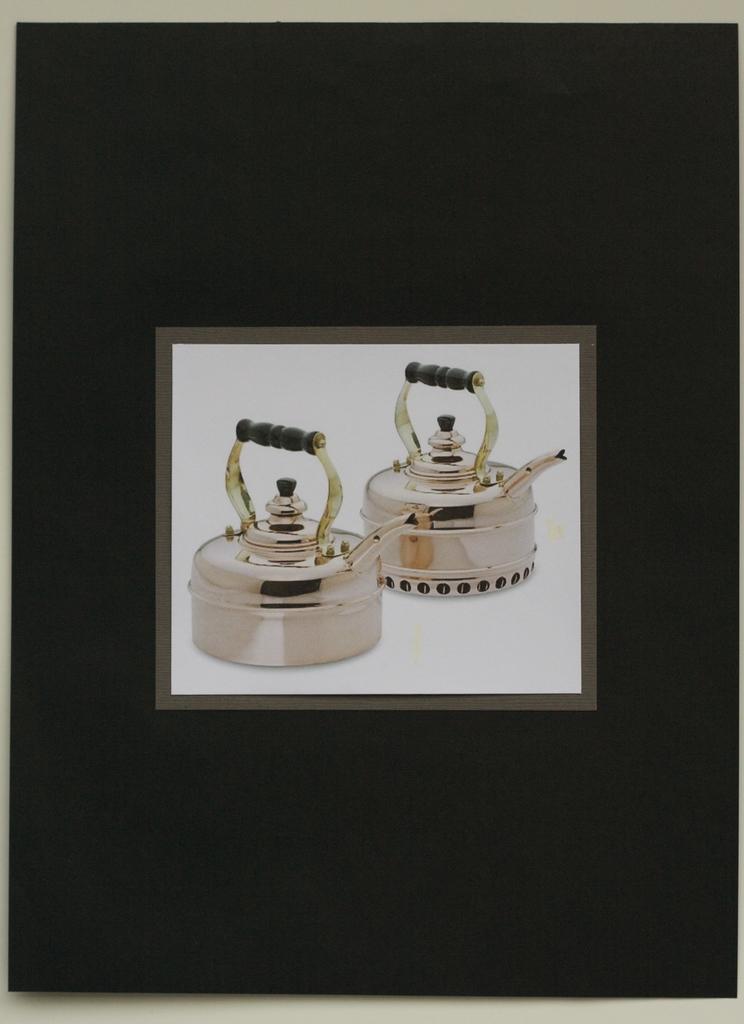Please provide a concise description of this image. In this image we can see one blackboard attached to the wall and two teapots photo attached to the blackboard. 